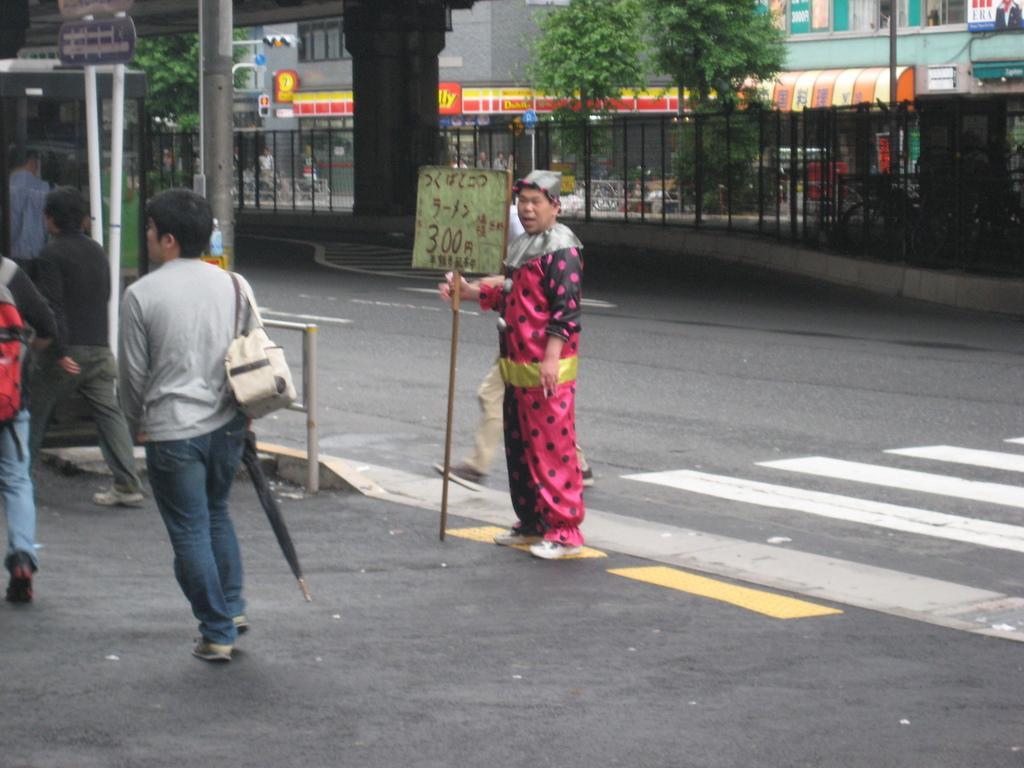Please provide a concise description of this image. In this picture we can see few people, in the middle of the image we can see a man, he is standing and he is holding a stick, in the background we can see few buildings, trees, hoardings and fence. 